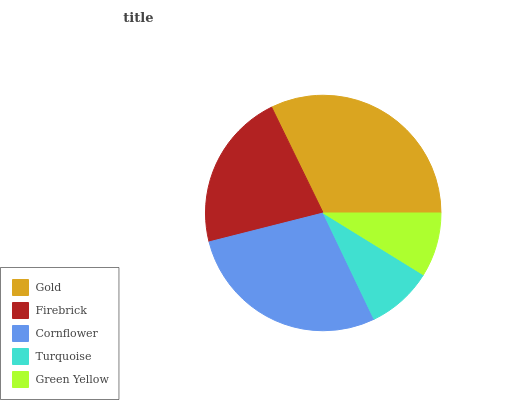Is Green Yellow the minimum?
Answer yes or no. Yes. Is Gold the maximum?
Answer yes or no. Yes. Is Firebrick the minimum?
Answer yes or no. No. Is Firebrick the maximum?
Answer yes or no. No. Is Gold greater than Firebrick?
Answer yes or no. Yes. Is Firebrick less than Gold?
Answer yes or no. Yes. Is Firebrick greater than Gold?
Answer yes or no. No. Is Gold less than Firebrick?
Answer yes or no. No. Is Firebrick the high median?
Answer yes or no. Yes. Is Firebrick the low median?
Answer yes or no. Yes. Is Cornflower the high median?
Answer yes or no. No. Is Cornflower the low median?
Answer yes or no. No. 